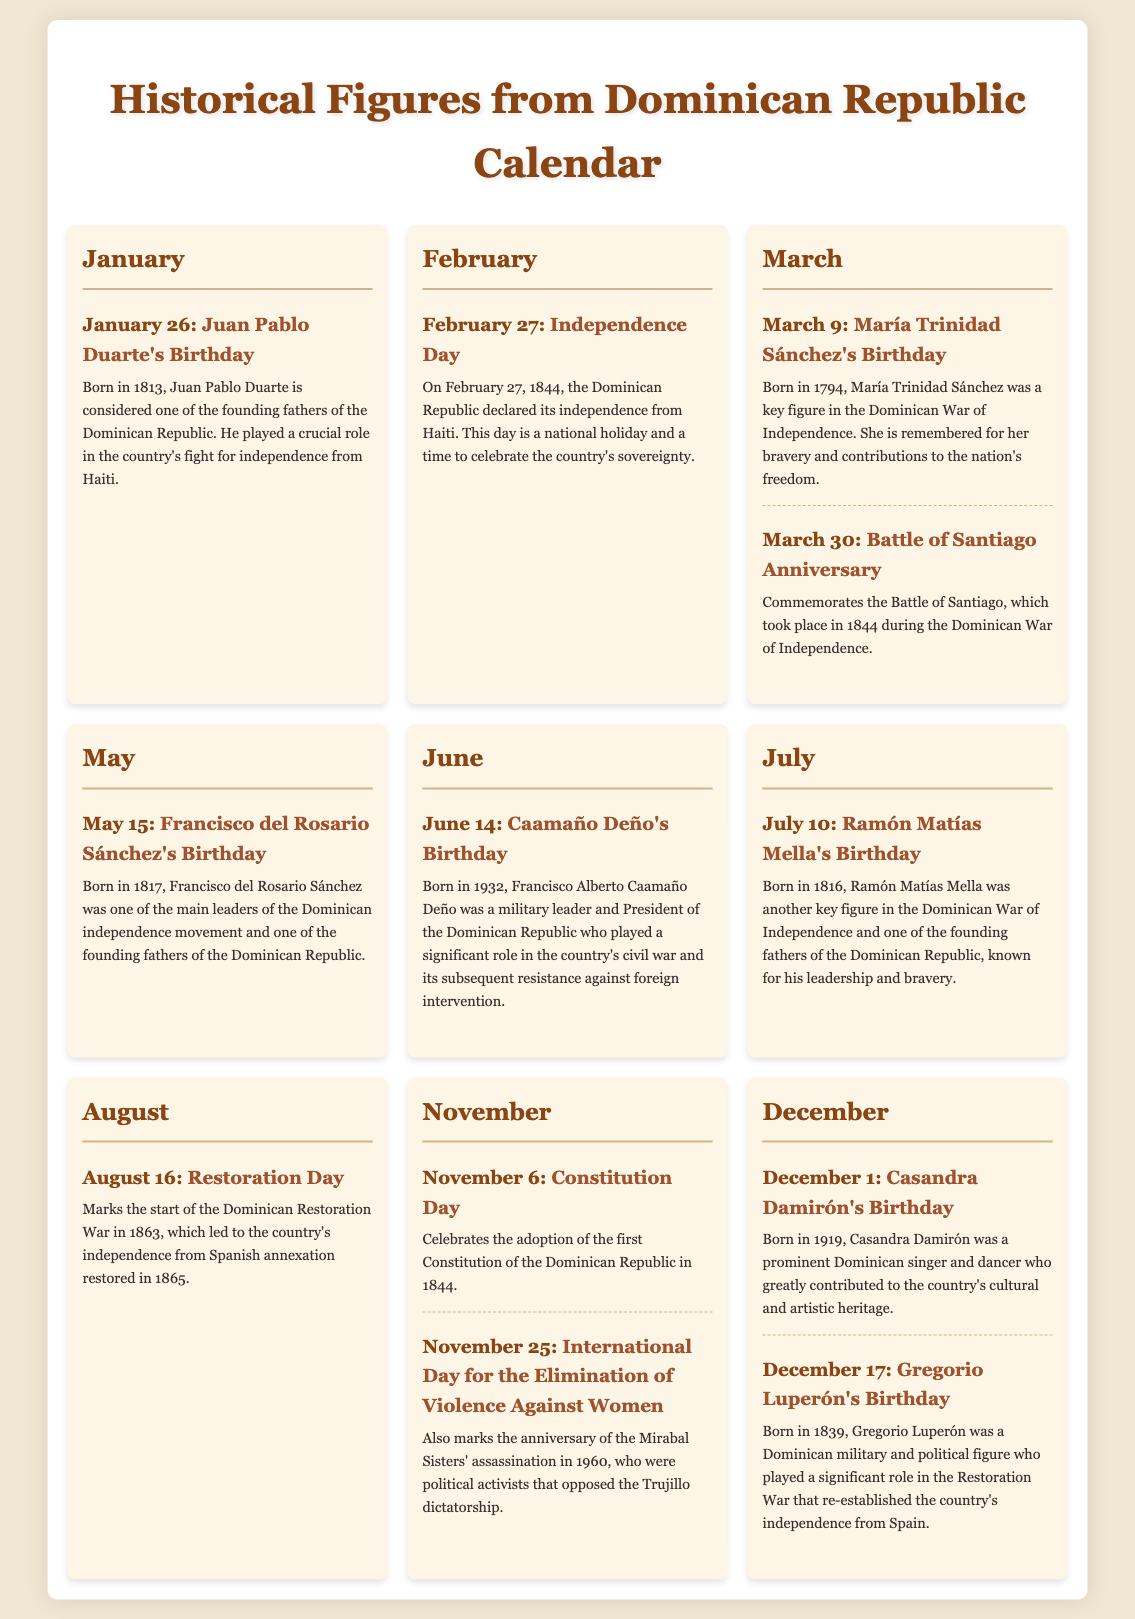What is the date of Juan Pablo Duarte's birthday? The birthday of Juan Pablo Duarte is found in the January section of the calendar.
Answer: January 26 Who is celebrated on February 27? February 27 is recognized as Independence Day in the document.
Answer: Independence Day What significant event is commemorated on March 30? The document states that March 30 commemorates a specific battle during the War of Independence.
Answer: Battle of Santiago In which year was Francisco del Rosario Sánchez born? The document provides the birth year of Francisco del Rosario Sánchez in May.
Answer: 1817 What is the purpose of August 16 in the calendar? August 16 marks the beginning of a war that restored the Dominican Republic's independence according to the document.
Answer: Restoration Day Who was assassinated on November 25? The document mentions the Mirabal Sisters' assassination on this date, indicating their significance in activism.
Answer: Mirabal Sisters What is celebrated on December 1? December 1 in the document is dedicated to honoring a specific cultural figure.
Answer: Casandra Damirón's Birthday Which year marks the adoption of the first Constitution of the Dominican Republic? From the document information, November 6 celebrates an event related to the country's Constitution.
Answer: 1844 